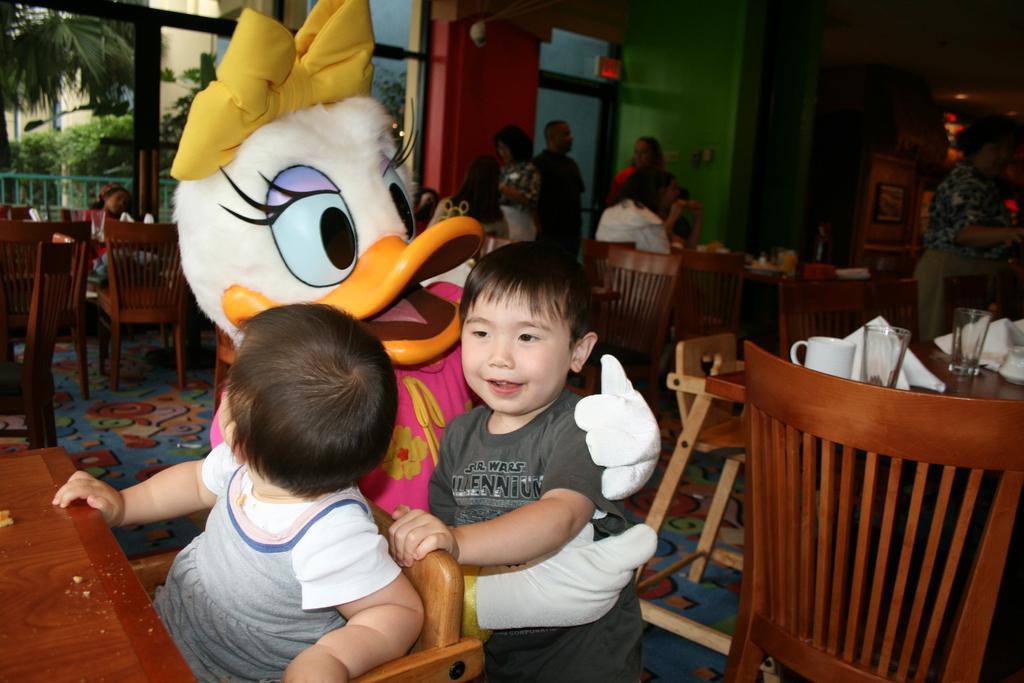In one or two sentences, can you explain what this image depicts? In this picture we can see a group of people sitting on chairs and some are standing and here a toy mask person is holding boy and he is smiling and in the background we can see trees, wall, windows, chairs and tables and on tables we have glasses, cups, tissue papers. 